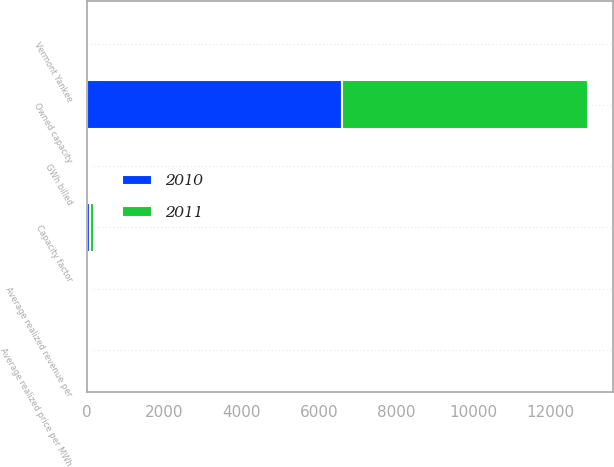Convert chart to OTSL. <chart><loc_0><loc_0><loc_500><loc_500><stacked_bar_chart><ecel><fcel>Owned capacity<fcel>GWh billed<fcel>Average realized price per MWh<fcel>Capacity factor<fcel>Average realized revenue per<fcel>Vermont Yankee<nl><fcel>2010<fcel>6599<fcel>59.1<fcel>54.48<fcel>93<fcel>54.73<fcel>25<nl><fcel>2011<fcel>6351<fcel>59.1<fcel>59.04<fcel>90<fcel>59.16<fcel>29<nl></chart> 